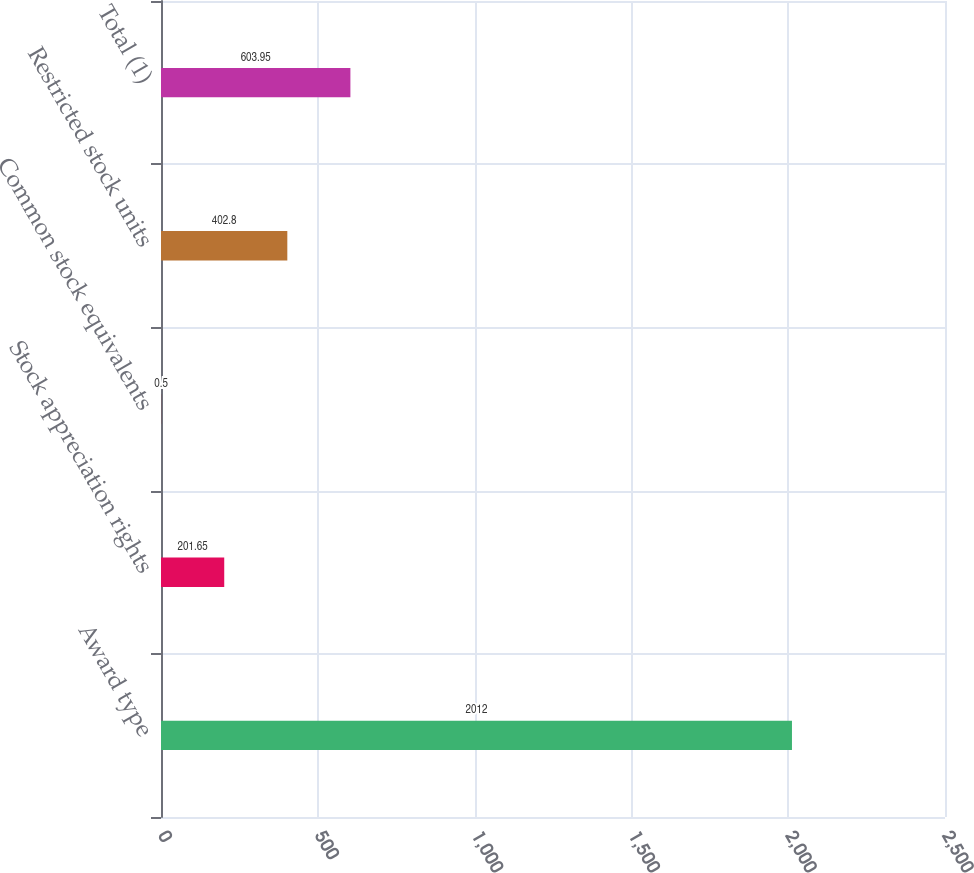<chart> <loc_0><loc_0><loc_500><loc_500><bar_chart><fcel>Award type<fcel>Stock appreciation rights<fcel>Common stock equivalents<fcel>Restricted stock units<fcel>Total (1)<nl><fcel>2012<fcel>201.65<fcel>0.5<fcel>402.8<fcel>603.95<nl></chart> 